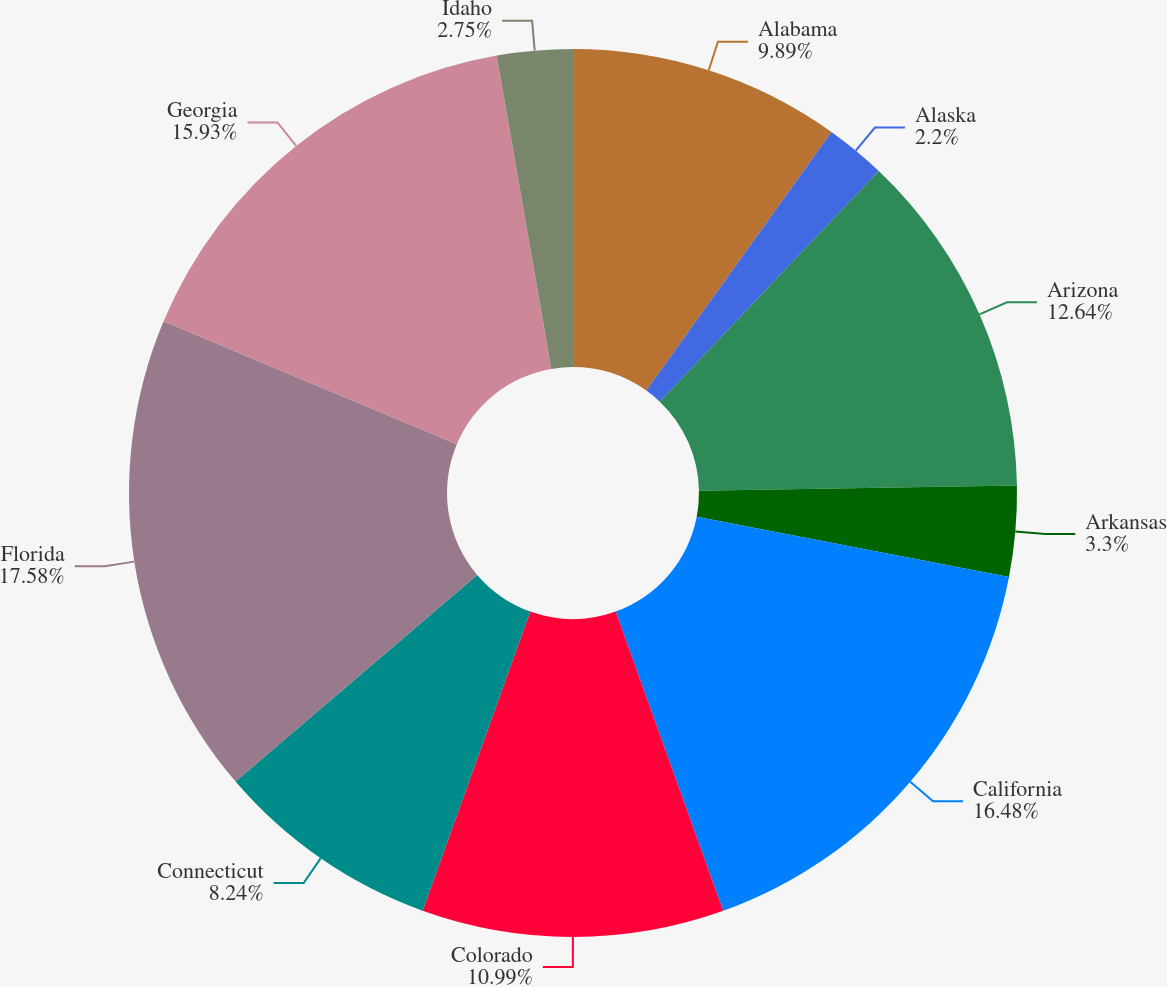Convert chart to OTSL. <chart><loc_0><loc_0><loc_500><loc_500><pie_chart><fcel>Alabama<fcel>Alaska<fcel>Arizona<fcel>Arkansas<fcel>California<fcel>Colorado<fcel>Connecticut<fcel>Florida<fcel>Georgia<fcel>Idaho<nl><fcel>9.89%<fcel>2.2%<fcel>12.64%<fcel>3.3%<fcel>16.48%<fcel>10.99%<fcel>8.24%<fcel>17.58%<fcel>15.93%<fcel>2.75%<nl></chart> 